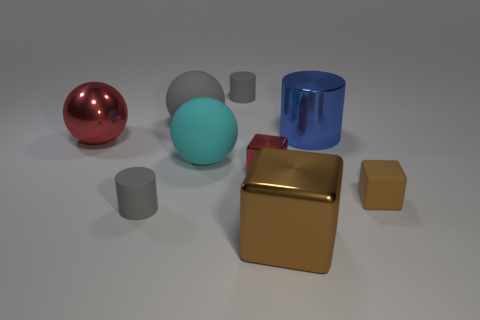Are there any other things that are the same material as the large red object?
Give a very brief answer. Yes. Is the number of metallic cylinders on the right side of the small brown matte cube greater than the number of red cubes?
Offer a very short reply. No. There is a block in front of the gray matte cylinder that is in front of the big gray rubber sphere; how many rubber balls are right of it?
Make the answer very short. 0. Do the ball that is behind the red shiny ball and the gray rubber cylinder behind the blue shiny cylinder have the same size?
Give a very brief answer. No. What material is the cyan thing behind the block on the left side of the brown metallic thing made of?
Ensure brevity in your answer.  Rubber. How many objects are either small cylinders that are behind the tiny rubber block or small objects?
Give a very brief answer. 4. Are there an equal number of rubber things that are behind the blue object and big cyan rubber objects that are in front of the small brown matte thing?
Provide a short and direct response. No. There is a small gray thing behind the red shiny thing left of the gray cylinder in front of the small rubber block; what is it made of?
Offer a terse response. Rubber. There is a metal thing that is both in front of the large shiny sphere and behind the tiny brown matte thing; what size is it?
Provide a succinct answer. Small. Is the small red metal object the same shape as the big brown metallic object?
Provide a succinct answer. Yes. 